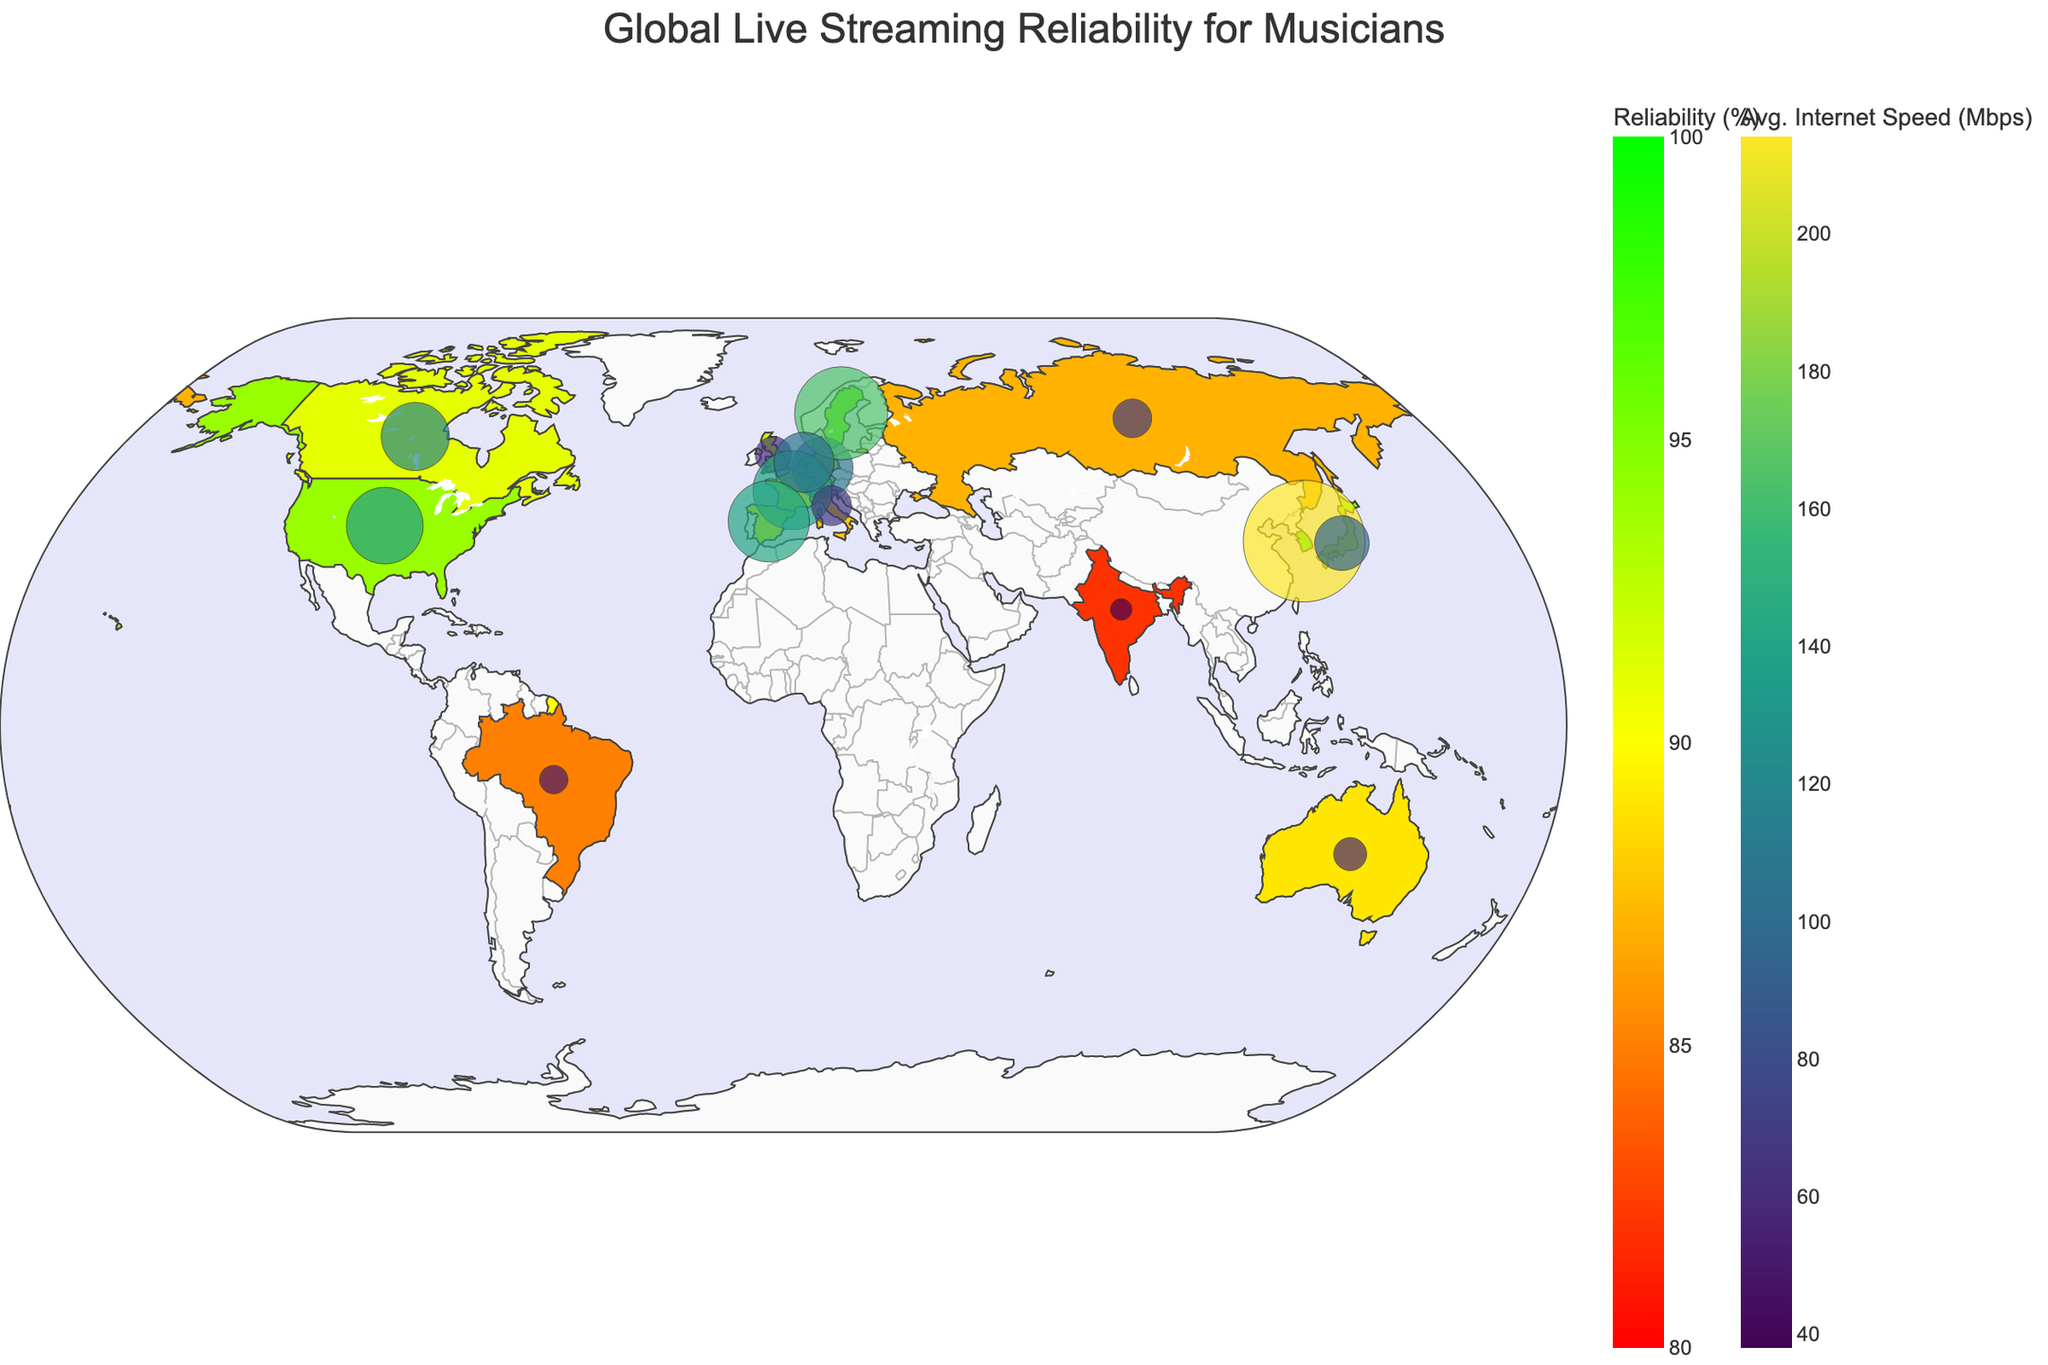Which country has the highest live streaming reliability percentage? Looking at the color shades and the values under "Live Streaming Reliability (%)", South Korea has the highest reliability percentage at 98%.
Answer: South Korea What is the range of Average Internet Speed (Mbps) across all countries shown on the map? The lowest average internet speed is in India at 38 Mbps, and the highest is in South Korea at 214 Mbps. The range is 214 - 38.
Answer: 176 Mbps Which countries have more than 95% live streaming reliability? By examining the shading representing reliability percentages and verifying the values, South Korea (98%), Japan (95%), and Sweden (96%) are the countries with more than 95% reliability.
Answer: South Korea, Japan, Sweden How does the average internet speed of Germany compare to that of the Netherlands? Germany has an average internet speed of 108 Mbps, while the Netherlands has 106 Mbps. Germany's speed is marginally higher.
Answer: Germany is higher What is the correlation between countries with high average internet speed and the percentage of musicians using live streaming? Countries with high speeds like South Korea (214 Mbps, 65%) and Sweden (164 Mbps, 71%) show varied musician streaming percentages, indicating no strong direct correlation.
Answer: No strong correlation Which country has the smallest bubble marker and what does it represent? India's bubble marker is the smallest, representing the lowest average internet speed of 38 Mbps.
Answer: India What is the average live streaming reliability (%) for European countries in the dataset? European countries in the dataset are Germany (93%), United Kingdom (92%), France (90%), Sweden (96%), Netherlands (94%), Italy (88%), Spain (91%). The average is (93+92+90+96+94+88+91) / 7 = 91.33%.
Answer: 91.33% What percentage of musicians in Japan uses live streaming and how reliable is the live streaming there? According to the dataset, 72% of Japanese musicians use live streaming, and the reliability is 95%.
Answer: 72%, 95% Which country has the highest percentage of musicians using live streaming, and what is its live streaming reliability? The United States has the highest percentage of musicians using live streaming at 78%, with a reliability of 94%.
Answer: United States, 78%, 94% How does Australia’s average internet speed compare to that of Brazil and Russia? Australia has an average internet speed of 58 Mbps, Brazil has 50 Mbps, and Russia has 68 Mbps. Australia is faster than Brazil but slower than Russia.
Answer: Faster than Brazil, Slower than Russia 